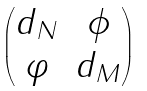<formula> <loc_0><loc_0><loc_500><loc_500>\begin{pmatrix} d _ { N } & \phi \\ \varphi & d _ { M } \end{pmatrix}</formula> 